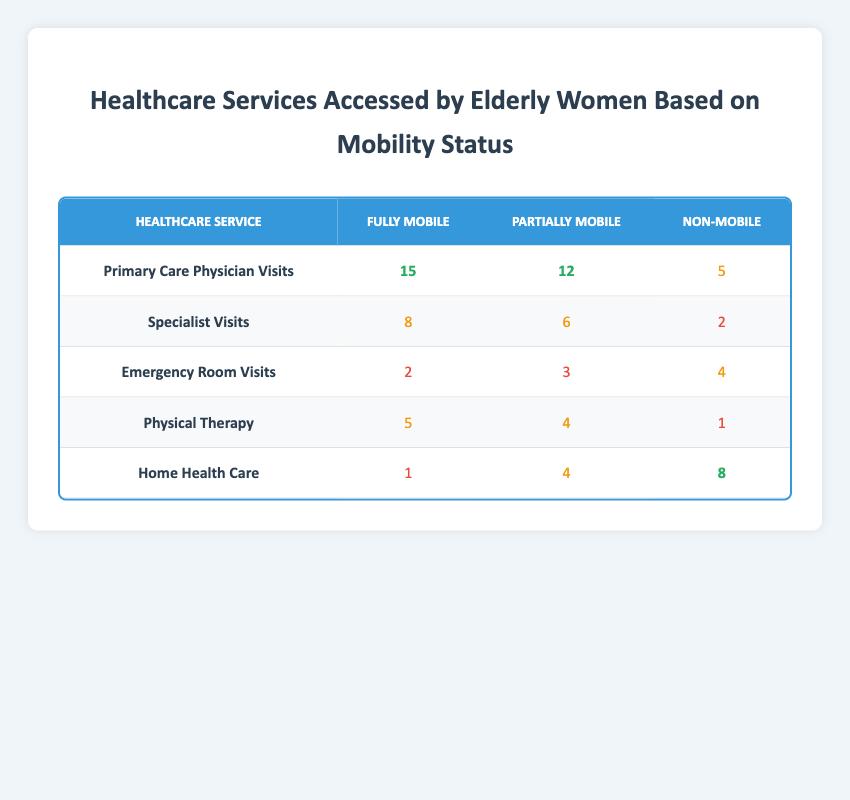What is the frequency of Primary Care Physician Visits for Non-Mobile elderly women? The table indicates that Non-Mobile elderly women had 5 Primary Care Physician Visits.
Answer: 5 How many Emergency Room Visits did Fully Mobile elderly women have compared to Partially Mobile women? For Fully Mobile elderly women, the frequency of Emergency Room Visits is 2, while for Partially Mobile women, it is 3. Therefore, Partially Mobile women had 1 more visit than Fully Mobile women.
Answer: 1 more visit True or false: More Non-Mobile elderly women accessed Home Health Care services than Fully Mobile women. The table shows that Non-Mobile elderly women accessed Home Health Care 8 times, while Fully Mobile women accessed it only 1 time, confirming that Non-Mobile women accessed more services.
Answer: True What is the total frequency of Specialist Visits across all mobility statuses? Adding the frequencies of Specialist Visits: Fully Mobile (8) + Partially Mobile (6) + Non-Mobile (2) equals 16.
Answer: 16 How does the frequency of Physical Therapy compare between Partially Mobile and Non-Mobile elderly women? The table shows that Partially Mobile women had 4 Physical Therapy visits, while Non-Mobile women had 1 visit. Thus, Partially Mobile women accessed Physical Therapy 3 more times.
Answer: 3 more times What is the average number of Home Health Care visits across all mobility statuses? The frequencies of Home Health Care are: Fully Mobile (1), Partially Mobile (4), Non-Mobile (8). The sum is 1 + 4 + 8 = 13, and there are 3 groups, so the average is 13/3, which is approximately 4.33.
Answer: 4.33 